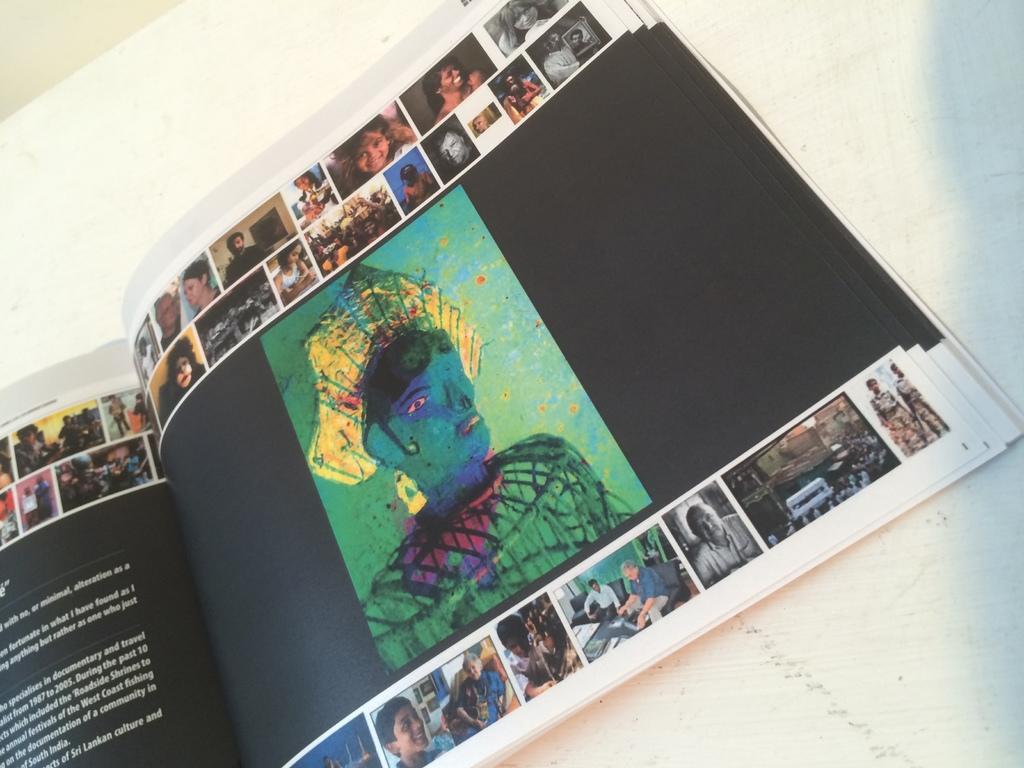In one or two sentences, can you explain what this image depicts? In this image we can see the book. There are many photos printed on the pages of the book. There is a painting in the image. There is a some text at the left side of the book. 